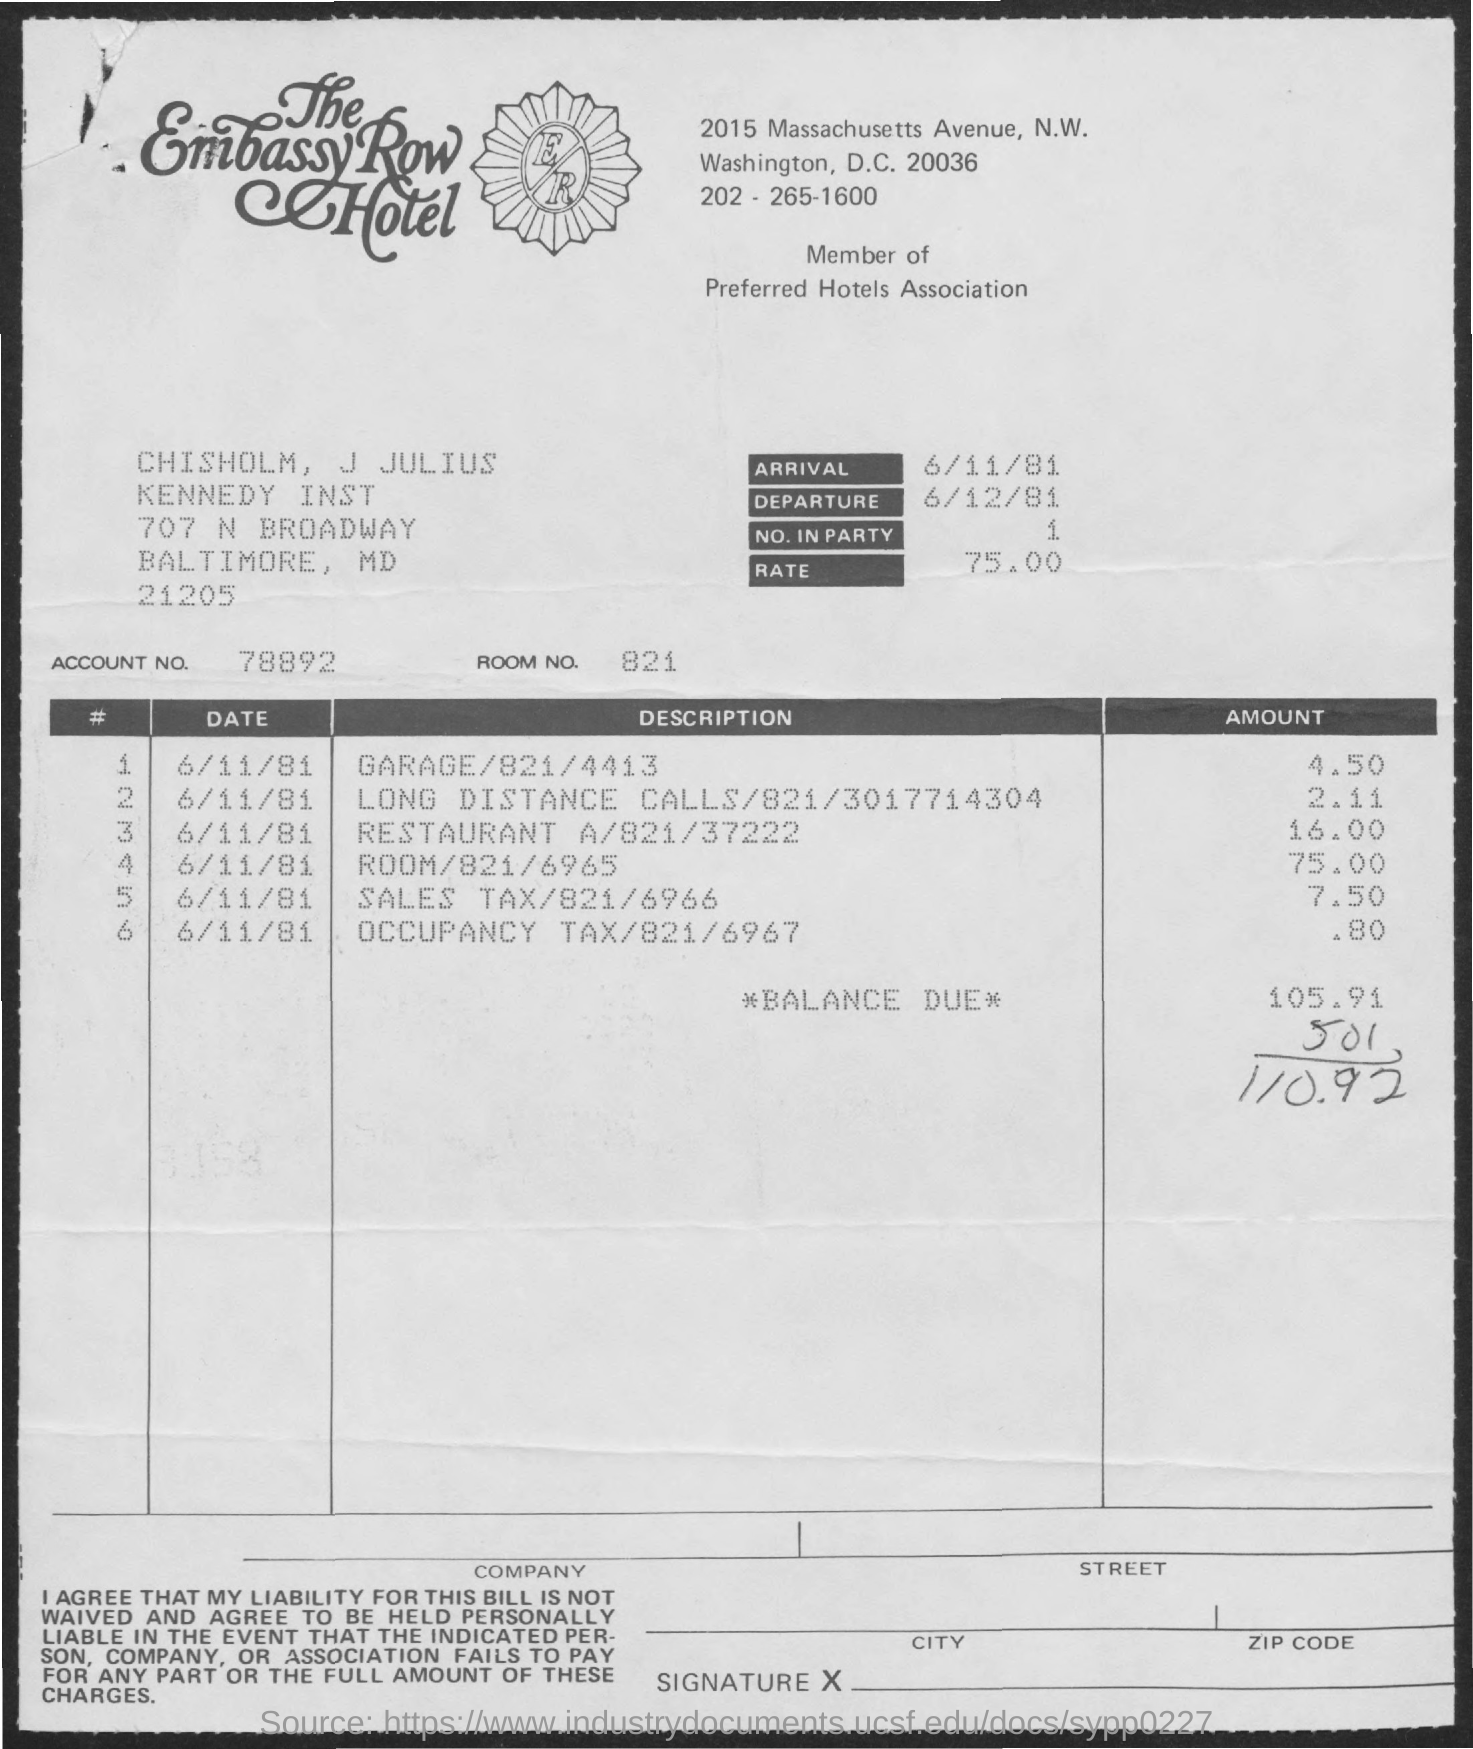Mention a couple of crucial points in this snapshot. The room number is 821.. There is a restaurant, named Restaurant A, and the amount listed is 16.00. The amount for Room 821 is $75.00. The arrival is expected to take place on June 11th, 1981. The amount for long distance calls is 2.11 cents per call, as shown on the phone number 3017714304. 